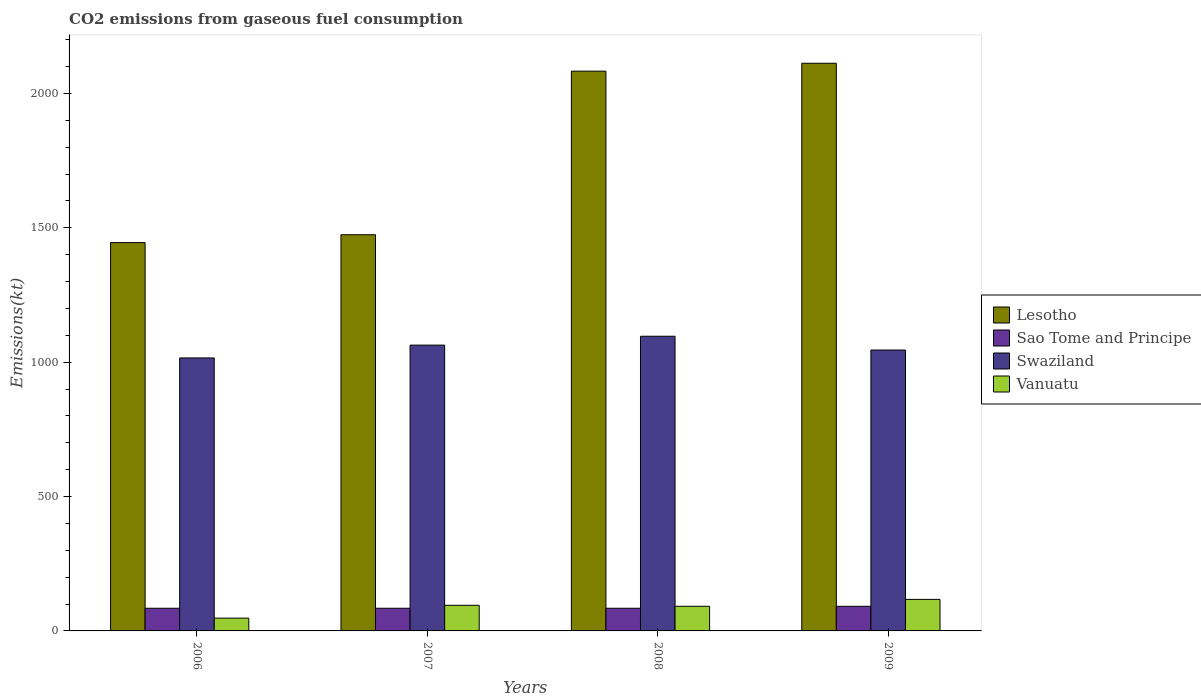How many different coloured bars are there?
Provide a short and direct response. 4. Are the number of bars per tick equal to the number of legend labels?
Give a very brief answer. Yes. Are the number of bars on each tick of the X-axis equal?
Give a very brief answer. Yes. How many bars are there on the 4th tick from the left?
Your response must be concise. 4. In how many cases, is the number of bars for a given year not equal to the number of legend labels?
Give a very brief answer. 0. What is the amount of CO2 emitted in Vanuatu in 2007?
Give a very brief answer. 95.34. Across all years, what is the maximum amount of CO2 emitted in Swaziland?
Provide a short and direct response. 1096.43. Across all years, what is the minimum amount of CO2 emitted in Sao Tome and Principe?
Offer a terse response. 84.34. In which year was the amount of CO2 emitted in Vanuatu maximum?
Your answer should be compact. 2009. In which year was the amount of CO2 emitted in Vanuatu minimum?
Ensure brevity in your answer.  2006. What is the total amount of CO2 emitted in Vanuatu in the graph?
Provide a succinct answer. 352.03. What is the difference between the amount of CO2 emitted in Swaziland in 2007 and that in 2009?
Offer a very short reply. 18.34. What is the difference between the amount of CO2 emitted in Vanuatu in 2008 and the amount of CO2 emitted in Lesotho in 2007?
Your answer should be very brief. -1382.46. What is the average amount of CO2 emitted in Lesotho per year?
Your response must be concise. 1778.5. In the year 2006, what is the difference between the amount of CO2 emitted in Lesotho and amount of CO2 emitted in Sao Tome and Principe?
Give a very brief answer. 1360.46. What is the ratio of the amount of CO2 emitted in Lesotho in 2008 to that in 2009?
Make the answer very short. 0.99. What is the difference between the highest and the second highest amount of CO2 emitted in Swaziland?
Offer a very short reply. 33. What is the difference between the highest and the lowest amount of CO2 emitted in Sao Tome and Principe?
Your answer should be compact. 7.33. Is the sum of the amount of CO2 emitted in Lesotho in 2006 and 2008 greater than the maximum amount of CO2 emitted in Swaziland across all years?
Offer a very short reply. Yes. What does the 4th bar from the left in 2008 represents?
Give a very brief answer. Vanuatu. What does the 1st bar from the right in 2007 represents?
Keep it short and to the point. Vanuatu. How many bars are there?
Offer a very short reply. 16. How many years are there in the graph?
Provide a succinct answer. 4. What is the difference between two consecutive major ticks on the Y-axis?
Offer a terse response. 500. Does the graph contain any zero values?
Your answer should be compact. No. Does the graph contain grids?
Your answer should be very brief. No. What is the title of the graph?
Your answer should be compact. CO2 emissions from gaseous fuel consumption. What is the label or title of the X-axis?
Your answer should be compact. Years. What is the label or title of the Y-axis?
Provide a short and direct response. Emissions(kt). What is the Emissions(kt) of Lesotho in 2006?
Offer a very short reply. 1444.8. What is the Emissions(kt) of Sao Tome and Principe in 2006?
Your response must be concise. 84.34. What is the Emissions(kt) in Swaziland in 2006?
Offer a very short reply. 1015.76. What is the Emissions(kt) in Vanuatu in 2006?
Provide a succinct answer. 47.67. What is the Emissions(kt) in Lesotho in 2007?
Your answer should be compact. 1474.13. What is the Emissions(kt) of Sao Tome and Principe in 2007?
Make the answer very short. 84.34. What is the Emissions(kt) in Swaziland in 2007?
Provide a short and direct response. 1063.43. What is the Emissions(kt) in Vanuatu in 2007?
Your answer should be compact. 95.34. What is the Emissions(kt) of Lesotho in 2008?
Ensure brevity in your answer.  2082.86. What is the Emissions(kt) of Sao Tome and Principe in 2008?
Provide a succinct answer. 84.34. What is the Emissions(kt) in Swaziland in 2008?
Offer a very short reply. 1096.43. What is the Emissions(kt) in Vanuatu in 2008?
Provide a short and direct response. 91.67. What is the Emissions(kt) of Lesotho in 2009?
Your answer should be compact. 2112.19. What is the Emissions(kt) in Sao Tome and Principe in 2009?
Keep it short and to the point. 91.67. What is the Emissions(kt) of Swaziland in 2009?
Give a very brief answer. 1045.1. What is the Emissions(kt) of Vanuatu in 2009?
Your answer should be very brief. 117.34. Across all years, what is the maximum Emissions(kt) of Lesotho?
Provide a succinct answer. 2112.19. Across all years, what is the maximum Emissions(kt) in Sao Tome and Principe?
Offer a very short reply. 91.67. Across all years, what is the maximum Emissions(kt) of Swaziland?
Ensure brevity in your answer.  1096.43. Across all years, what is the maximum Emissions(kt) in Vanuatu?
Make the answer very short. 117.34. Across all years, what is the minimum Emissions(kt) in Lesotho?
Give a very brief answer. 1444.8. Across all years, what is the minimum Emissions(kt) in Sao Tome and Principe?
Provide a succinct answer. 84.34. Across all years, what is the minimum Emissions(kt) of Swaziland?
Offer a very short reply. 1015.76. Across all years, what is the minimum Emissions(kt) in Vanuatu?
Offer a very short reply. 47.67. What is the total Emissions(kt) in Lesotho in the graph?
Ensure brevity in your answer.  7113.98. What is the total Emissions(kt) in Sao Tome and Principe in the graph?
Ensure brevity in your answer.  344.7. What is the total Emissions(kt) in Swaziland in the graph?
Make the answer very short. 4220.72. What is the total Emissions(kt) in Vanuatu in the graph?
Ensure brevity in your answer.  352.03. What is the difference between the Emissions(kt) in Lesotho in 2006 and that in 2007?
Offer a terse response. -29.34. What is the difference between the Emissions(kt) in Swaziland in 2006 and that in 2007?
Offer a very short reply. -47.67. What is the difference between the Emissions(kt) of Vanuatu in 2006 and that in 2007?
Your answer should be very brief. -47.67. What is the difference between the Emissions(kt) of Lesotho in 2006 and that in 2008?
Provide a short and direct response. -638.06. What is the difference between the Emissions(kt) of Sao Tome and Principe in 2006 and that in 2008?
Your answer should be very brief. 0. What is the difference between the Emissions(kt) of Swaziland in 2006 and that in 2008?
Ensure brevity in your answer.  -80.67. What is the difference between the Emissions(kt) of Vanuatu in 2006 and that in 2008?
Offer a very short reply. -44. What is the difference between the Emissions(kt) in Lesotho in 2006 and that in 2009?
Your answer should be very brief. -667.39. What is the difference between the Emissions(kt) in Sao Tome and Principe in 2006 and that in 2009?
Make the answer very short. -7.33. What is the difference between the Emissions(kt) of Swaziland in 2006 and that in 2009?
Your response must be concise. -29.34. What is the difference between the Emissions(kt) of Vanuatu in 2006 and that in 2009?
Your answer should be compact. -69.67. What is the difference between the Emissions(kt) in Lesotho in 2007 and that in 2008?
Give a very brief answer. -608.72. What is the difference between the Emissions(kt) in Swaziland in 2007 and that in 2008?
Your answer should be compact. -33. What is the difference between the Emissions(kt) of Vanuatu in 2007 and that in 2008?
Provide a succinct answer. 3.67. What is the difference between the Emissions(kt) in Lesotho in 2007 and that in 2009?
Make the answer very short. -638.06. What is the difference between the Emissions(kt) in Sao Tome and Principe in 2007 and that in 2009?
Your answer should be compact. -7.33. What is the difference between the Emissions(kt) of Swaziland in 2007 and that in 2009?
Provide a succinct answer. 18.34. What is the difference between the Emissions(kt) of Vanuatu in 2007 and that in 2009?
Provide a succinct answer. -22. What is the difference between the Emissions(kt) of Lesotho in 2008 and that in 2009?
Offer a very short reply. -29.34. What is the difference between the Emissions(kt) in Sao Tome and Principe in 2008 and that in 2009?
Give a very brief answer. -7.33. What is the difference between the Emissions(kt) in Swaziland in 2008 and that in 2009?
Your answer should be very brief. 51.34. What is the difference between the Emissions(kt) of Vanuatu in 2008 and that in 2009?
Your answer should be compact. -25.67. What is the difference between the Emissions(kt) in Lesotho in 2006 and the Emissions(kt) in Sao Tome and Principe in 2007?
Provide a succinct answer. 1360.46. What is the difference between the Emissions(kt) in Lesotho in 2006 and the Emissions(kt) in Swaziland in 2007?
Offer a terse response. 381.37. What is the difference between the Emissions(kt) in Lesotho in 2006 and the Emissions(kt) in Vanuatu in 2007?
Your answer should be very brief. 1349.46. What is the difference between the Emissions(kt) in Sao Tome and Principe in 2006 and the Emissions(kt) in Swaziland in 2007?
Your response must be concise. -979.09. What is the difference between the Emissions(kt) of Sao Tome and Principe in 2006 and the Emissions(kt) of Vanuatu in 2007?
Offer a very short reply. -11. What is the difference between the Emissions(kt) of Swaziland in 2006 and the Emissions(kt) of Vanuatu in 2007?
Ensure brevity in your answer.  920.42. What is the difference between the Emissions(kt) of Lesotho in 2006 and the Emissions(kt) of Sao Tome and Principe in 2008?
Ensure brevity in your answer.  1360.46. What is the difference between the Emissions(kt) of Lesotho in 2006 and the Emissions(kt) of Swaziland in 2008?
Keep it short and to the point. 348.37. What is the difference between the Emissions(kt) of Lesotho in 2006 and the Emissions(kt) of Vanuatu in 2008?
Keep it short and to the point. 1353.12. What is the difference between the Emissions(kt) in Sao Tome and Principe in 2006 and the Emissions(kt) in Swaziland in 2008?
Offer a very short reply. -1012.09. What is the difference between the Emissions(kt) of Sao Tome and Principe in 2006 and the Emissions(kt) of Vanuatu in 2008?
Offer a very short reply. -7.33. What is the difference between the Emissions(kt) of Swaziland in 2006 and the Emissions(kt) of Vanuatu in 2008?
Make the answer very short. 924.08. What is the difference between the Emissions(kt) of Lesotho in 2006 and the Emissions(kt) of Sao Tome and Principe in 2009?
Your response must be concise. 1353.12. What is the difference between the Emissions(kt) of Lesotho in 2006 and the Emissions(kt) of Swaziland in 2009?
Your response must be concise. 399.7. What is the difference between the Emissions(kt) in Lesotho in 2006 and the Emissions(kt) in Vanuatu in 2009?
Provide a succinct answer. 1327.45. What is the difference between the Emissions(kt) in Sao Tome and Principe in 2006 and the Emissions(kt) in Swaziland in 2009?
Provide a short and direct response. -960.75. What is the difference between the Emissions(kt) of Sao Tome and Principe in 2006 and the Emissions(kt) of Vanuatu in 2009?
Keep it short and to the point. -33. What is the difference between the Emissions(kt) in Swaziland in 2006 and the Emissions(kt) in Vanuatu in 2009?
Your answer should be compact. 898.41. What is the difference between the Emissions(kt) of Lesotho in 2007 and the Emissions(kt) of Sao Tome and Principe in 2008?
Keep it short and to the point. 1389.79. What is the difference between the Emissions(kt) in Lesotho in 2007 and the Emissions(kt) in Swaziland in 2008?
Give a very brief answer. 377.7. What is the difference between the Emissions(kt) in Lesotho in 2007 and the Emissions(kt) in Vanuatu in 2008?
Your response must be concise. 1382.46. What is the difference between the Emissions(kt) in Sao Tome and Principe in 2007 and the Emissions(kt) in Swaziland in 2008?
Your answer should be very brief. -1012.09. What is the difference between the Emissions(kt) in Sao Tome and Principe in 2007 and the Emissions(kt) in Vanuatu in 2008?
Provide a short and direct response. -7.33. What is the difference between the Emissions(kt) of Swaziland in 2007 and the Emissions(kt) of Vanuatu in 2008?
Ensure brevity in your answer.  971.75. What is the difference between the Emissions(kt) of Lesotho in 2007 and the Emissions(kt) of Sao Tome and Principe in 2009?
Your answer should be compact. 1382.46. What is the difference between the Emissions(kt) in Lesotho in 2007 and the Emissions(kt) in Swaziland in 2009?
Your answer should be compact. 429.04. What is the difference between the Emissions(kt) in Lesotho in 2007 and the Emissions(kt) in Vanuatu in 2009?
Make the answer very short. 1356.79. What is the difference between the Emissions(kt) of Sao Tome and Principe in 2007 and the Emissions(kt) of Swaziland in 2009?
Make the answer very short. -960.75. What is the difference between the Emissions(kt) of Sao Tome and Principe in 2007 and the Emissions(kt) of Vanuatu in 2009?
Make the answer very short. -33. What is the difference between the Emissions(kt) of Swaziland in 2007 and the Emissions(kt) of Vanuatu in 2009?
Give a very brief answer. 946.09. What is the difference between the Emissions(kt) in Lesotho in 2008 and the Emissions(kt) in Sao Tome and Principe in 2009?
Provide a short and direct response. 1991.18. What is the difference between the Emissions(kt) in Lesotho in 2008 and the Emissions(kt) in Swaziland in 2009?
Give a very brief answer. 1037.76. What is the difference between the Emissions(kt) in Lesotho in 2008 and the Emissions(kt) in Vanuatu in 2009?
Your answer should be very brief. 1965.51. What is the difference between the Emissions(kt) of Sao Tome and Principe in 2008 and the Emissions(kt) of Swaziland in 2009?
Your answer should be very brief. -960.75. What is the difference between the Emissions(kt) in Sao Tome and Principe in 2008 and the Emissions(kt) in Vanuatu in 2009?
Provide a succinct answer. -33. What is the difference between the Emissions(kt) in Swaziland in 2008 and the Emissions(kt) in Vanuatu in 2009?
Provide a short and direct response. 979.09. What is the average Emissions(kt) of Lesotho per year?
Your response must be concise. 1778.49. What is the average Emissions(kt) in Sao Tome and Principe per year?
Provide a short and direct response. 86.17. What is the average Emissions(kt) of Swaziland per year?
Provide a short and direct response. 1055.18. What is the average Emissions(kt) of Vanuatu per year?
Ensure brevity in your answer.  88.01. In the year 2006, what is the difference between the Emissions(kt) of Lesotho and Emissions(kt) of Sao Tome and Principe?
Ensure brevity in your answer.  1360.46. In the year 2006, what is the difference between the Emissions(kt) in Lesotho and Emissions(kt) in Swaziland?
Offer a very short reply. 429.04. In the year 2006, what is the difference between the Emissions(kt) of Lesotho and Emissions(kt) of Vanuatu?
Keep it short and to the point. 1397.13. In the year 2006, what is the difference between the Emissions(kt) of Sao Tome and Principe and Emissions(kt) of Swaziland?
Ensure brevity in your answer.  -931.42. In the year 2006, what is the difference between the Emissions(kt) of Sao Tome and Principe and Emissions(kt) of Vanuatu?
Provide a short and direct response. 36.67. In the year 2006, what is the difference between the Emissions(kt) of Swaziland and Emissions(kt) of Vanuatu?
Offer a very short reply. 968.09. In the year 2007, what is the difference between the Emissions(kt) of Lesotho and Emissions(kt) of Sao Tome and Principe?
Offer a very short reply. 1389.79. In the year 2007, what is the difference between the Emissions(kt) in Lesotho and Emissions(kt) in Swaziland?
Provide a short and direct response. 410.7. In the year 2007, what is the difference between the Emissions(kt) of Lesotho and Emissions(kt) of Vanuatu?
Your response must be concise. 1378.79. In the year 2007, what is the difference between the Emissions(kt) in Sao Tome and Principe and Emissions(kt) in Swaziland?
Provide a succinct answer. -979.09. In the year 2007, what is the difference between the Emissions(kt) in Sao Tome and Principe and Emissions(kt) in Vanuatu?
Provide a short and direct response. -11. In the year 2007, what is the difference between the Emissions(kt) of Swaziland and Emissions(kt) of Vanuatu?
Your response must be concise. 968.09. In the year 2008, what is the difference between the Emissions(kt) of Lesotho and Emissions(kt) of Sao Tome and Principe?
Make the answer very short. 1998.52. In the year 2008, what is the difference between the Emissions(kt) of Lesotho and Emissions(kt) of Swaziland?
Your response must be concise. 986.42. In the year 2008, what is the difference between the Emissions(kt) in Lesotho and Emissions(kt) in Vanuatu?
Make the answer very short. 1991.18. In the year 2008, what is the difference between the Emissions(kt) of Sao Tome and Principe and Emissions(kt) of Swaziland?
Your answer should be compact. -1012.09. In the year 2008, what is the difference between the Emissions(kt) in Sao Tome and Principe and Emissions(kt) in Vanuatu?
Keep it short and to the point. -7.33. In the year 2008, what is the difference between the Emissions(kt) of Swaziland and Emissions(kt) of Vanuatu?
Your answer should be compact. 1004.76. In the year 2009, what is the difference between the Emissions(kt) in Lesotho and Emissions(kt) in Sao Tome and Principe?
Give a very brief answer. 2020.52. In the year 2009, what is the difference between the Emissions(kt) in Lesotho and Emissions(kt) in Swaziland?
Give a very brief answer. 1067.1. In the year 2009, what is the difference between the Emissions(kt) in Lesotho and Emissions(kt) in Vanuatu?
Offer a terse response. 1994.85. In the year 2009, what is the difference between the Emissions(kt) of Sao Tome and Principe and Emissions(kt) of Swaziland?
Your answer should be compact. -953.42. In the year 2009, what is the difference between the Emissions(kt) of Sao Tome and Principe and Emissions(kt) of Vanuatu?
Provide a succinct answer. -25.67. In the year 2009, what is the difference between the Emissions(kt) of Swaziland and Emissions(kt) of Vanuatu?
Offer a very short reply. 927.75. What is the ratio of the Emissions(kt) in Lesotho in 2006 to that in 2007?
Keep it short and to the point. 0.98. What is the ratio of the Emissions(kt) in Swaziland in 2006 to that in 2007?
Your response must be concise. 0.96. What is the ratio of the Emissions(kt) in Vanuatu in 2006 to that in 2007?
Provide a succinct answer. 0.5. What is the ratio of the Emissions(kt) in Lesotho in 2006 to that in 2008?
Offer a terse response. 0.69. What is the ratio of the Emissions(kt) in Sao Tome and Principe in 2006 to that in 2008?
Ensure brevity in your answer.  1. What is the ratio of the Emissions(kt) of Swaziland in 2006 to that in 2008?
Give a very brief answer. 0.93. What is the ratio of the Emissions(kt) of Vanuatu in 2006 to that in 2008?
Provide a short and direct response. 0.52. What is the ratio of the Emissions(kt) in Lesotho in 2006 to that in 2009?
Offer a very short reply. 0.68. What is the ratio of the Emissions(kt) in Sao Tome and Principe in 2006 to that in 2009?
Your response must be concise. 0.92. What is the ratio of the Emissions(kt) in Swaziland in 2006 to that in 2009?
Provide a short and direct response. 0.97. What is the ratio of the Emissions(kt) in Vanuatu in 2006 to that in 2009?
Make the answer very short. 0.41. What is the ratio of the Emissions(kt) in Lesotho in 2007 to that in 2008?
Offer a terse response. 0.71. What is the ratio of the Emissions(kt) of Sao Tome and Principe in 2007 to that in 2008?
Your answer should be compact. 1. What is the ratio of the Emissions(kt) of Swaziland in 2007 to that in 2008?
Offer a very short reply. 0.97. What is the ratio of the Emissions(kt) of Vanuatu in 2007 to that in 2008?
Ensure brevity in your answer.  1.04. What is the ratio of the Emissions(kt) in Lesotho in 2007 to that in 2009?
Your answer should be very brief. 0.7. What is the ratio of the Emissions(kt) of Swaziland in 2007 to that in 2009?
Keep it short and to the point. 1.02. What is the ratio of the Emissions(kt) in Vanuatu in 2007 to that in 2009?
Your answer should be very brief. 0.81. What is the ratio of the Emissions(kt) of Lesotho in 2008 to that in 2009?
Give a very brief answer. 0.99. What is the ratio of the Emissions(kt) in Sao Tome and Principe in 2008 to that in 2009?
Give a very brief answer. 0.92. What is the ratio of the Emissions(kt) of Swaziland in 2008 to that in 2009?
Offer a very short reply. 1.05. What is the ratio of the Emissions(kt) of Vanuatu in 2008 to that in 2009?
Ensure brevity in your answer.  0.78. What is the difference between the highest and the second highest Emissions(kt) of Lesotho?
Offer a very short reply. 29.34. What is the difference between the highest and the second highest Emissions(kt) in Sao Tome and Principe?
Provide a short and direct response. 7.33. What is the difference between the highest and the second highest Emissions(kt) of Swaziland?
Provide a short and direct response. 33. What is the difference between the highest and the second highest Emissions(kt) in Vanuatu?
Your answer should be very brief. 22. What is the difference between the highest and the lowest Emissions(kt) in Lesotho?
Offer a terse response. 667.39. What is the difference between the highest and the lowest Emissions(kt) in Sao Tome and Principe?
Offer a terse response. 7.33. What is the difference between the highest and the lowest Emissions(kt) of Swaziland?
Make the answer very short. 80.67. What is the difference between the highest and the lowest Emissions(kt) in Vanuatu?
Give a very brief answer. 69.67. 